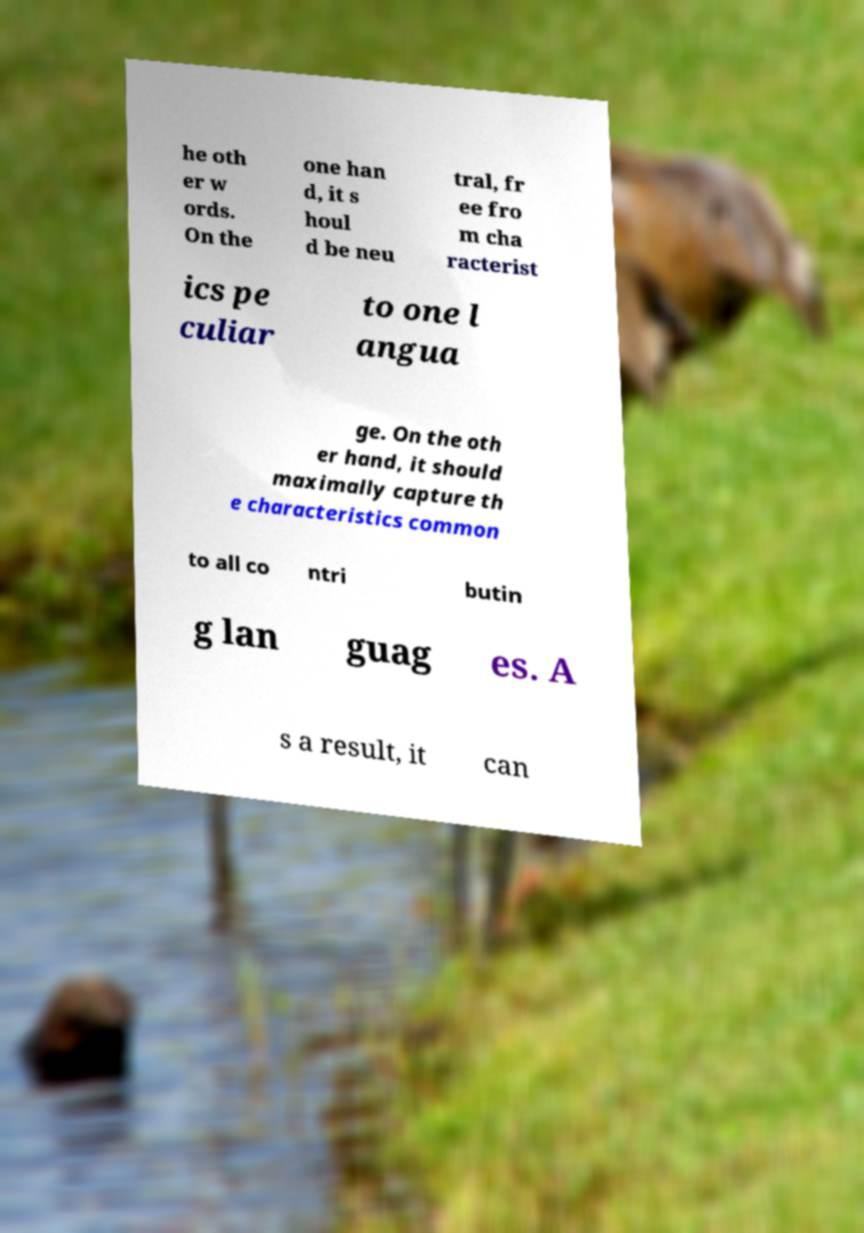Could you assist in decoding the text presented in this image and type it out clearly? he oth er w ords. On the one han d, it s houl d be neu tral, fr ee fro m cha racterist ics pe culiar to one l angua ge. On the oth er hand, it should maximally capture th e characteristics common to all co ntri butin g lan guag es. A s a result, it can 